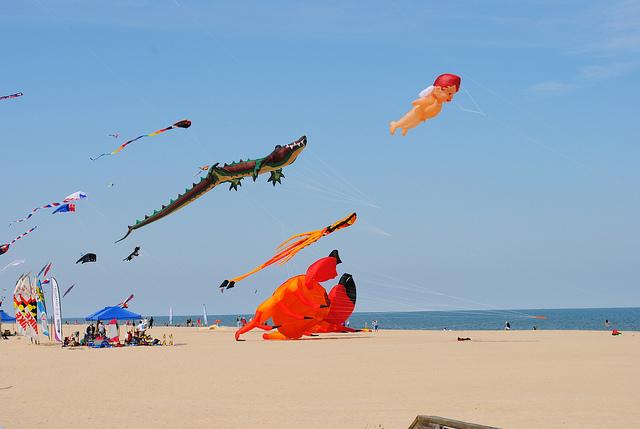Are there any people?
Give a very brief answer. Yes. Is the beach crowded?
Short answer required. No. How many pandas are there?
Short answer required. 0. What objects are in the sky in this picture?
Concise answer only. Kites. 